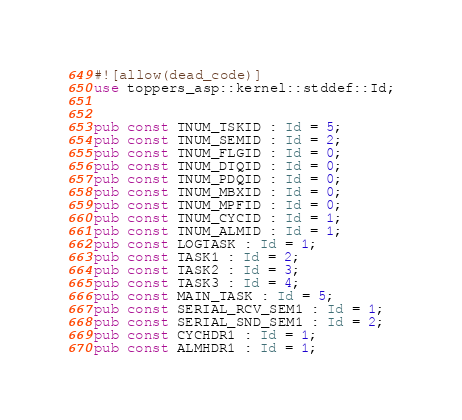<code> <loc_0><loc_0><loc_500><loc_500><_Rust_>#![allow(dead_code)]
use toppers_asp::kernel::stddef::Id;


pub const TNUM_TSKID : Id = 5;
pub const TNUM_SEMID : Id = 2;
pub const TNUM_FLGID : Id = 0;
pub const TNUM_DTQID : Id = 0;
pub const TNUM_PDQID : Id = 0;
pub const TNUM_MBXID : Id = 0;
pub const TNUM_MPFID : Id = 0;
pub const TNUM_CYCID : Id = 1;
pub const TNUM_ALMID : Id = 1;
pub const LOGTASK : Id = 1;
pub const TASK1 : Id = 2;
pub const TASK2 : Id = 3;
pub const TASK3 : Id = 4;
pub const MAIN_TASK : Id = 5;
pub const SERIAL_RCV_SEM1 : Id = 1;
pub const SERIAL_SND_SEM1 : Id = 2;
pub const CYCHDR1 : Id = 1;
pub const ALMHDR1 : Id = 1;
</code> 